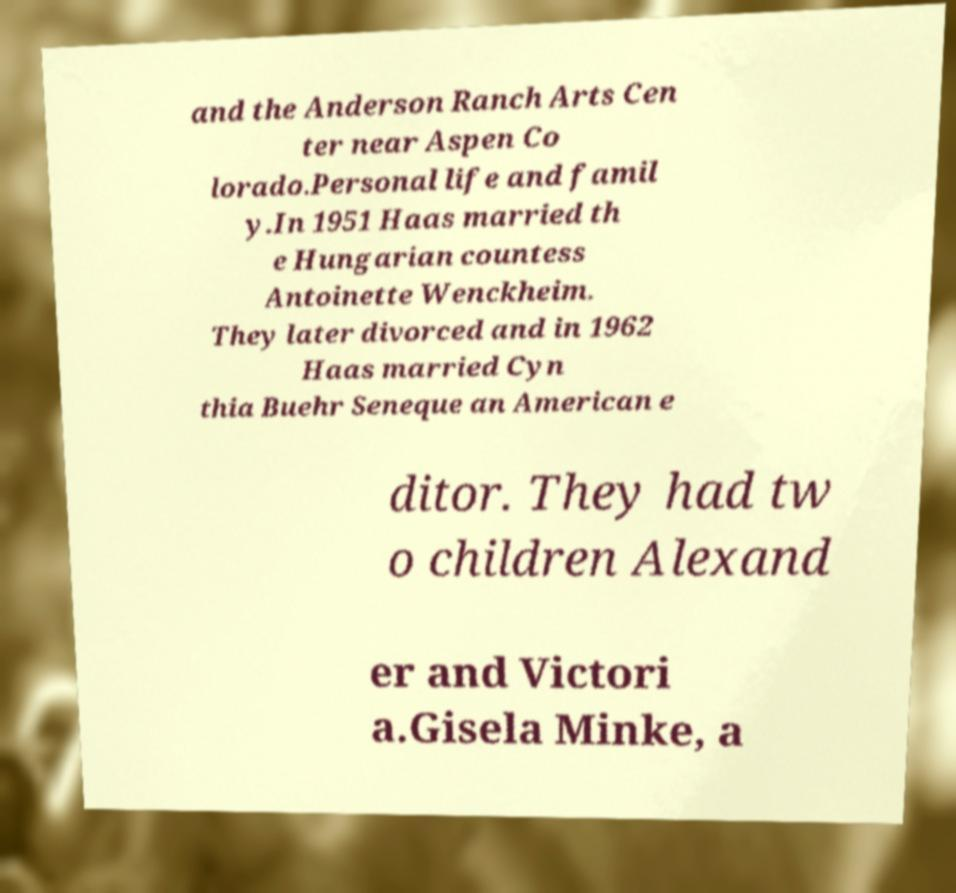Could you assist in decoding the text presented in this image and type it out clearly? and the Anderson Ranch Arts Cen ter near Aspen Co lorado.Personal life and famil y.In 1951 Haas married th e Hungarian countess Antoinette Wenckheim. They later divorced and in 1962 Haas married Cyn thia Buehr Seneque an American e ditor. They had tw o children Alexand er and Victori a.Gisela Minke, a 